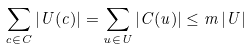Convert formula to latex. <formula><loc_0><loc_0><loc_500><loc_500>\sum _ { c \in C } \left | U ( c ) \right | = \sum _ { u \in U } \left | C ( u ) \right | \leq m \left | U \right |</formula> 